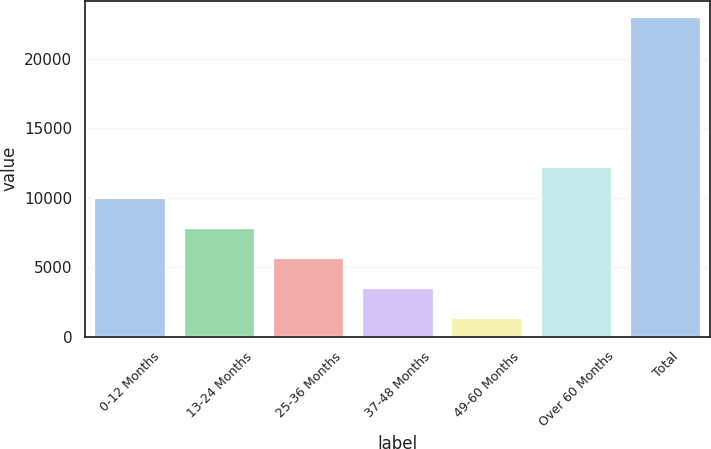Convert chart. <chart><loc_0><loc_0><loc_500><loc_500><bar_chart><fcel>0-12 Months<fcel>13-24 Months<fcel>25-36 Months<fcel>37-48 Months<fcel>49-60 Months<fcel>Over 60 Months<fcel>Total<nl><fcel>10019<fcel>7845<fcel>5671<fcel>3497<fcel>1323<fcel>12193<fcel>23063<nl></chart> 